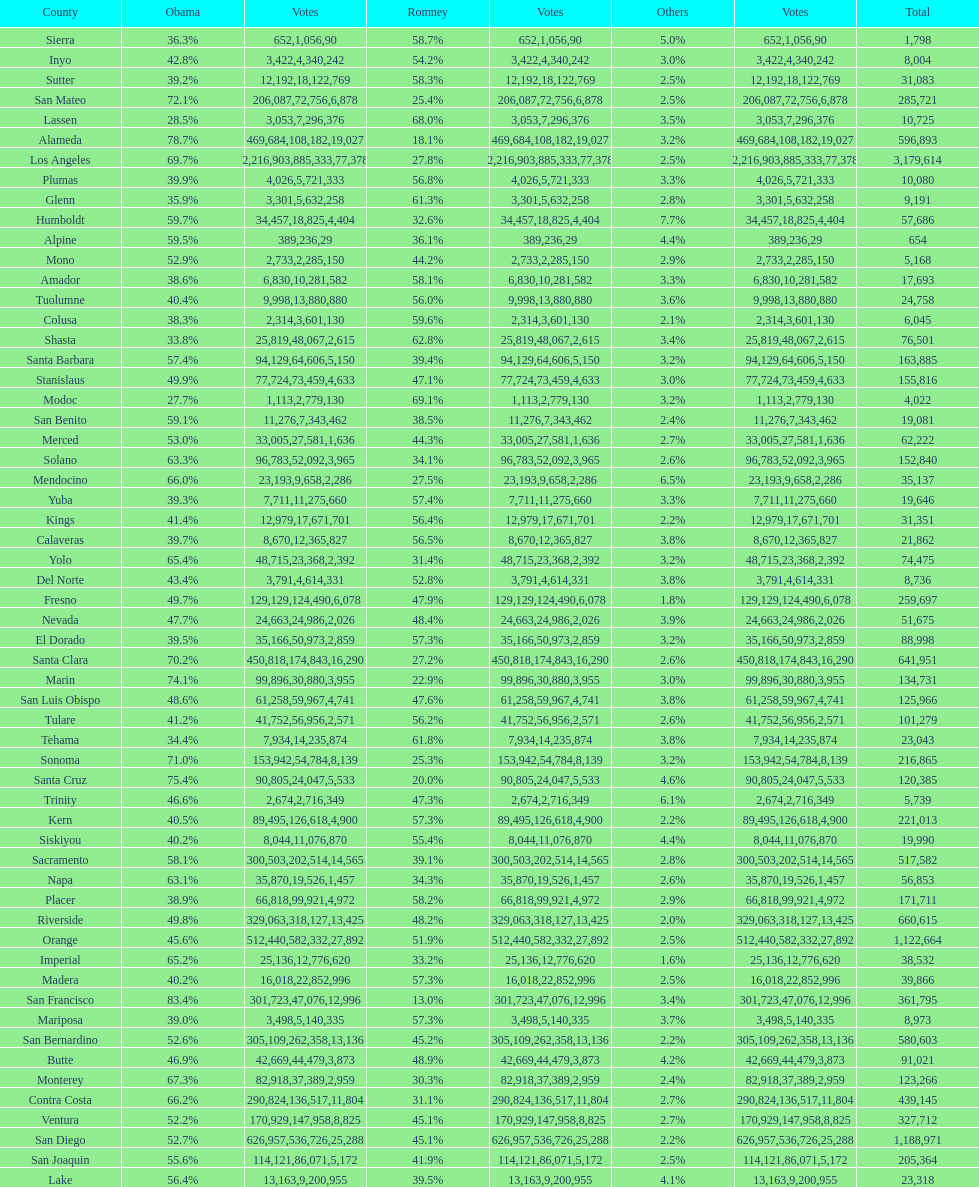Did romney earn more or less votes than obama did in alameda county? Less. 